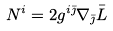<formula> <loc_0><loc_0><loc_500><loc_500>N ^ { i } = 2 g ^ { i \bar { \jmath } } \nabla _ { \bar { \jmath } } \bar { L }</formula> 